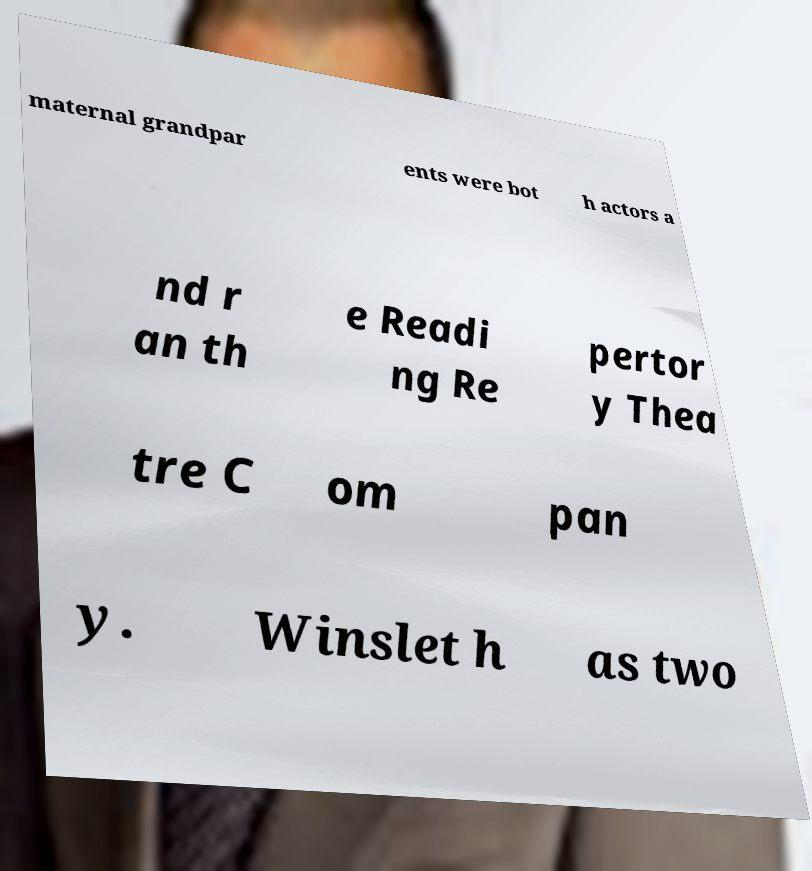Can you read and provide the text displayed in the image?This photo seems to have some interesting text. Can you extract and type it out for me? maternal grandpar ents were bot h actors a nd r an th e Readi ng Re pertor y Thea tre C om pan y. Winslet h as two 